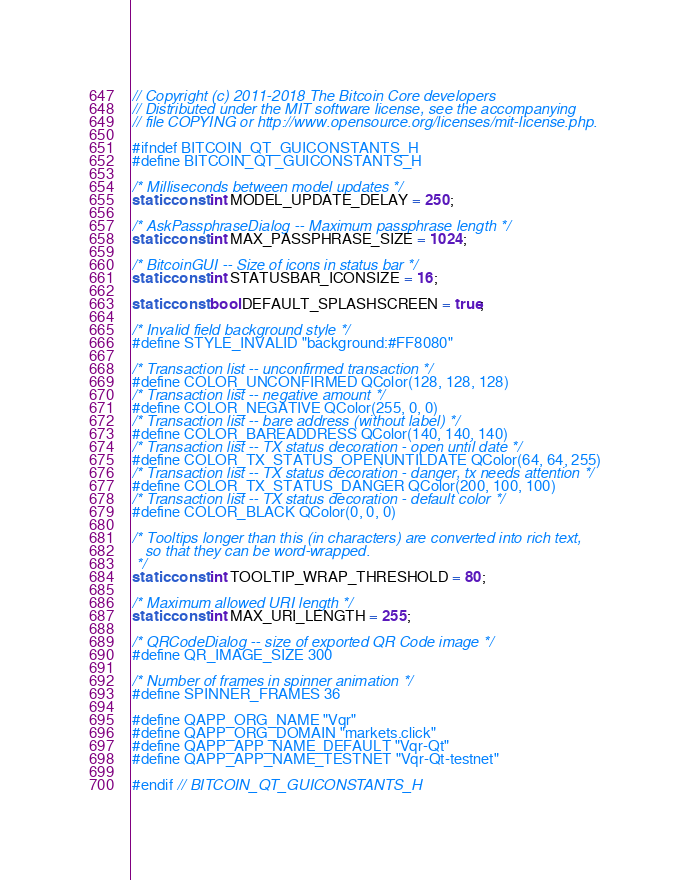<code> <loc_0><loc_0><loc_500><loc_500><_C_>// Copyright (c) 2011-2018 The Bitcoin Core developers
// Distributed under the MIT software license, see the accompanying
// file COPYING or http://www.opensource.org/licenses/mit-license.php.

#ifndef BITCOIN_QT_GUICONSTANTS_H
#define BITCOIN_QT_GUICONSTANTS_H

/* Milliseconds between model updates */
static const int MODEL_UPDATE_DELAY = 250;

/* AskPassphraseDialog -- Maximum passphrase length */
static const int MAX_PASSPHRASE_SIZE = 1024;

/* BitcoinGUI -- Size of icons in status bar */
static const int STATUSBAR_ICONSIZE = 16;

static const bool DEFAULT_SPLASHSCREEN = true;

/* Invalid field background style */
#define STYLE_INVALID "background:#FF8080"

/* Transaction list -- unconfirmed transaction */
#define COLOR_UNCONFIRMED QColor(128, 128, 128)
/* Transaction list -- negative amount */
#define COLOR_NEGATIVE QColor(255, 0, 0)
/* Transaction list -- bare address (without label) */
#define COLOR_BAREADDRESS QColor(140, 140, 140)
/* Transaction list -- TX status decoration - open until date */
#define COLOR_TX_STATUS_OPENUNTILDATE QColor(64, 64, 255)
/* Transaction list -- TX status decoration - danger, tx needs attention */
#define COLOR_TX_STATUS_DANGER QColor(200, 100, 100)
/* Transaction list -- TX status decoration - default color */
#define COLOR_BLACK QColor(0, 0, 0)

/* Tooltips longer than this (in characters) are converted into rich text,
   so that they can be word-wrapped.
 */
static const int TOOLTIP_WRAP_THRESHOLD = 80;

/* Maximum allowed URI length */
static const int MAX_URI_LENGTH = 255;

/* QRCodeDialog -- size of exported QR Code image */
#define QR_IMAGE_SIZE 300

/* Number of frames in spinner animation */
#define SPINNER_FRAMES 36

#define QAPP_ORG_NAME "Vqr"
#define QAPP_ORG_DOMAIN "markets.click"
#define QAPP_APP_NAME_DEFAULT "Vqr-Qt"
#define QAPP_APP_NAME_TESTNET "Vqr-Qt-testnet"

#endif // BITCOIN_QT_GUICONSTANTS_H
</code> 